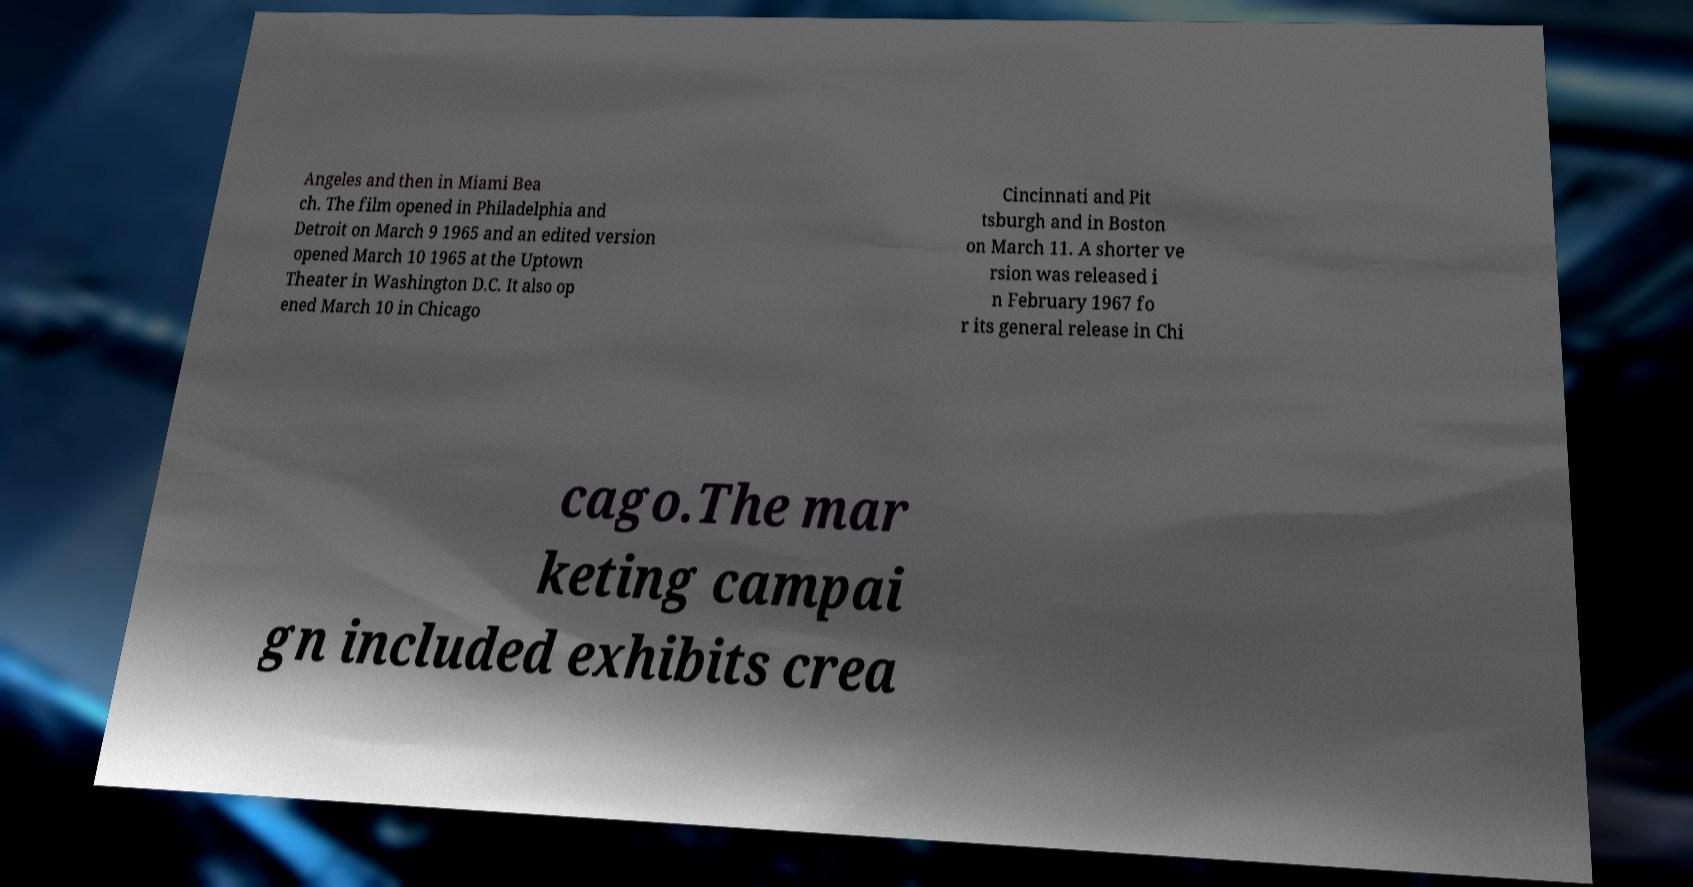I need the written content from this picture converted into text. Can you do that? Angeles and then in Miami Bea ch. The film opened in Philadelphia and Detroit on March 9 1965 and an edited version opened March 10 1965 at the Uptown Theater in Washington D.C. It also op ened March 10 in Chicago Cincinnati and Pit tsburgh and in Boston on March 11. A shorter ve rsion was released i n February 1967 fo r its general release in Chi cago.The mar keting campai gn included exhibits crea 